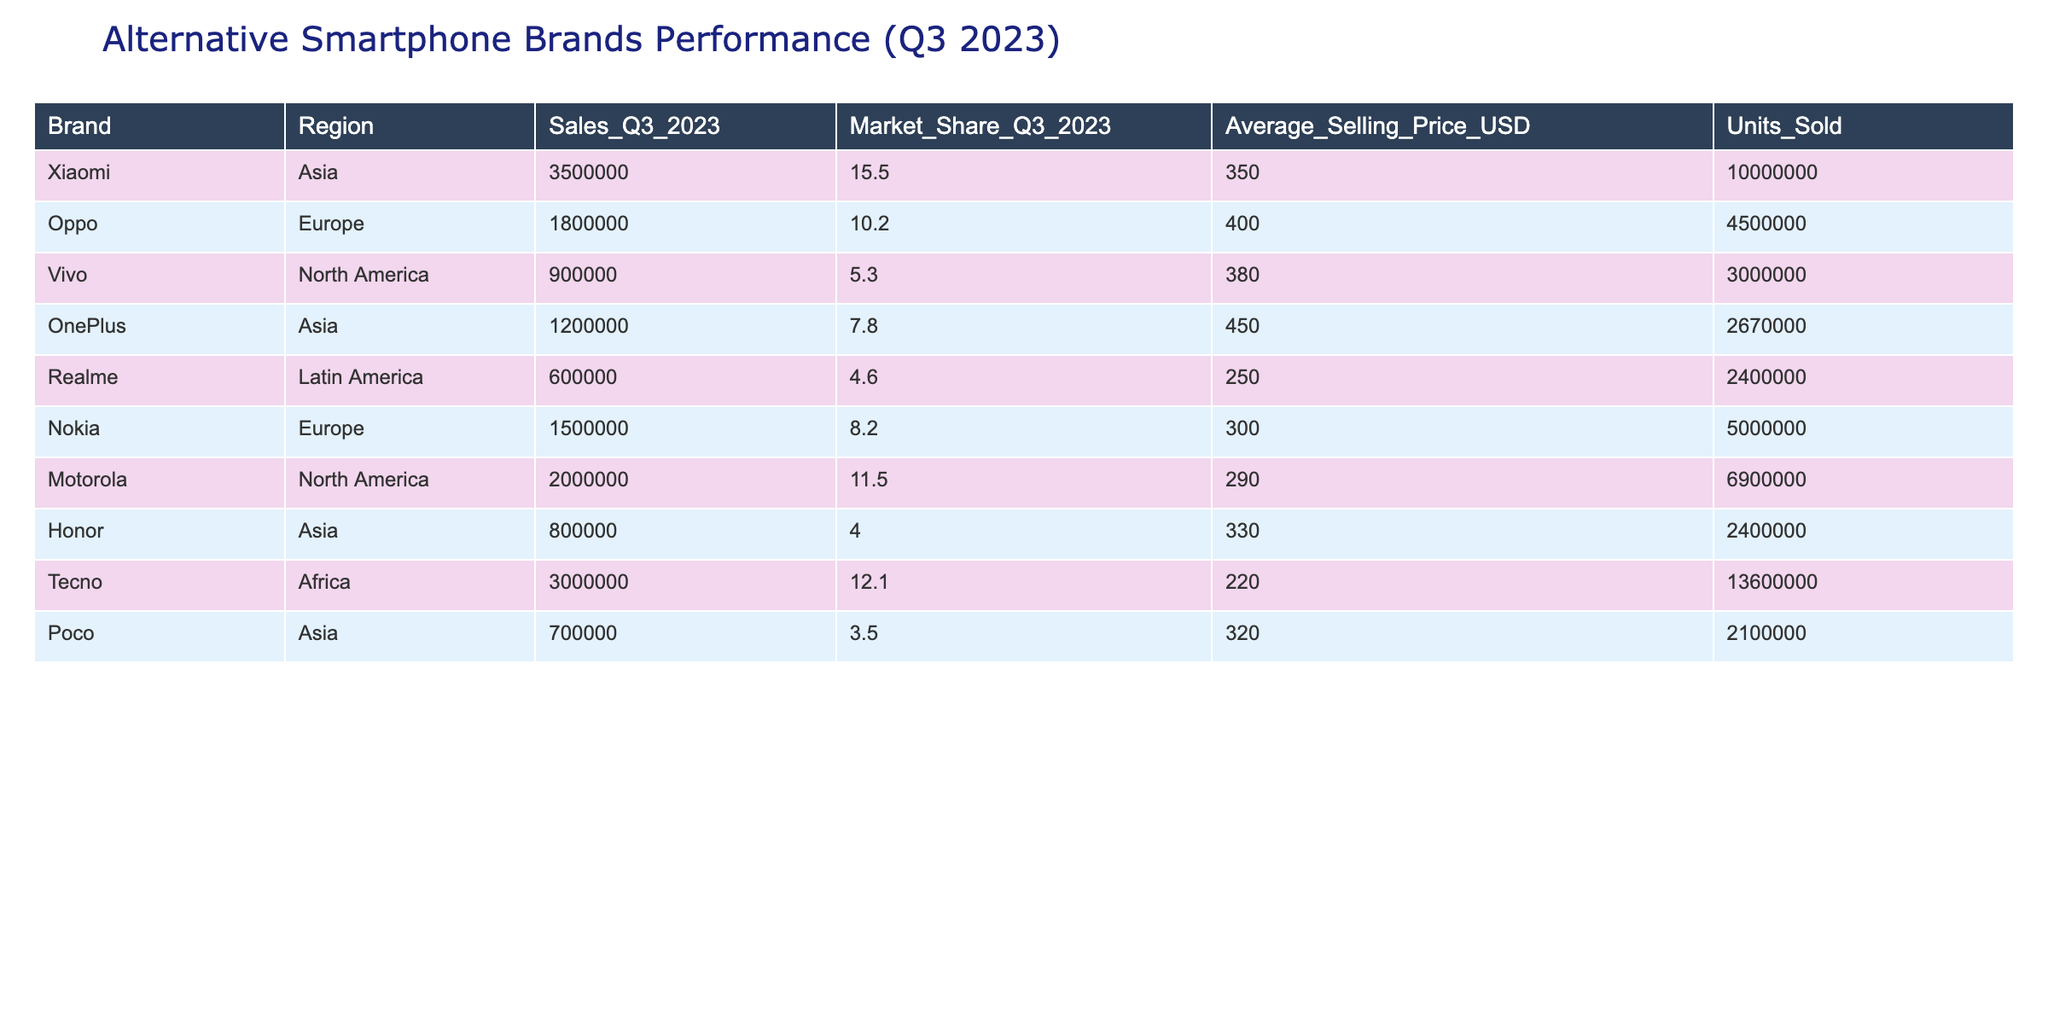What is the total number of units sold by Xiaomi in Q3 2023? The table states that Xiaomi sold 10,000,000 units in Q3 2023 as per the "Units_Sold" column corresponding to its row in the table.
Answer: 10,000,000 Which region has the highest market share for an alternative smartphone brand? By examining the table, Tecno holds the highest market share at 12.1% in Africa, making it the brand with the highest market share across all listed regions.
Answer: Africa How much did Motorola earn from sales in Q3 2023? The sales figure for Motorola in Q3 2023 is 2,000,000 USD, found in the "Sales_Q3_2023" column corresponding to its entry in the table.
Answer: 2,000,000 What is the average selling price of all smartphone brands listed in the table? To find the average selling price, sum the average selling prices: (350 + 400 + 380 + 450 + 250 + 300 + 290 + 330 + 220)/9 = 327.22 USD. Therefore, the average price is approximately 327.22 USD.
Answer: 327.22 Did any brand's sales exceed 3 million units in Q3 2023? According to the table, Xiaomi is the only brand with sales exceeding 3 million units, as it shows 10 million units sold, confirming that the statement is true.
Answer: Yes Which brand had the lowest sales in Q3 2023 and what were those sales? When looking at the "Sales_Q3_2023" column, Realme had the lowest sales figure at 600,000 USD, as indicated in the corresponding row.
Answer: 600,000 How many units did Oppo sell compared to Vivo? Oppo sold 4,500,000 units while Vivo sold 3,000,000 units. The difference is 4,500,000 - 3,000,000 = 1,500,000 fewer units sold by Vivo compared to Oppo.
Answer: 1,500,000 Is the market share of Poco greater than that of Realme? From the "Market_Share_Q3_2023" column, Poco has a market share of 3.5% while Realme’s is 4.6%. Since 3.5% is less than 4.6%, the answer is false.
Answer: No What is the total sales amount for all brands combined in the table? To find the total sales amount, sum all the values from the "Sales_Q3_2023" column: (3500000 + 1800000 + 900000 + 1200000 + 600000 + 1500000 + 2000000 + 800000 + 3000000 + 700000) = 16500000 USD.
Answer: 16,500,000 